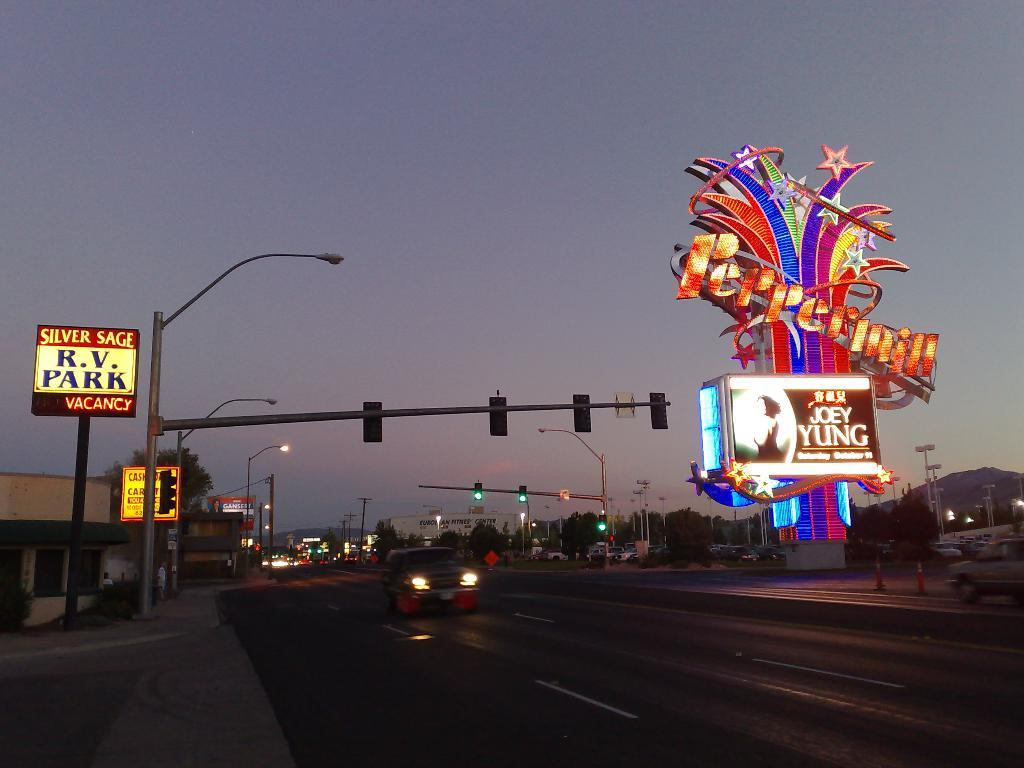<image>
Share a concise interpretation of the image provided. Joey Yung will be performing at the Pepermill in October. 